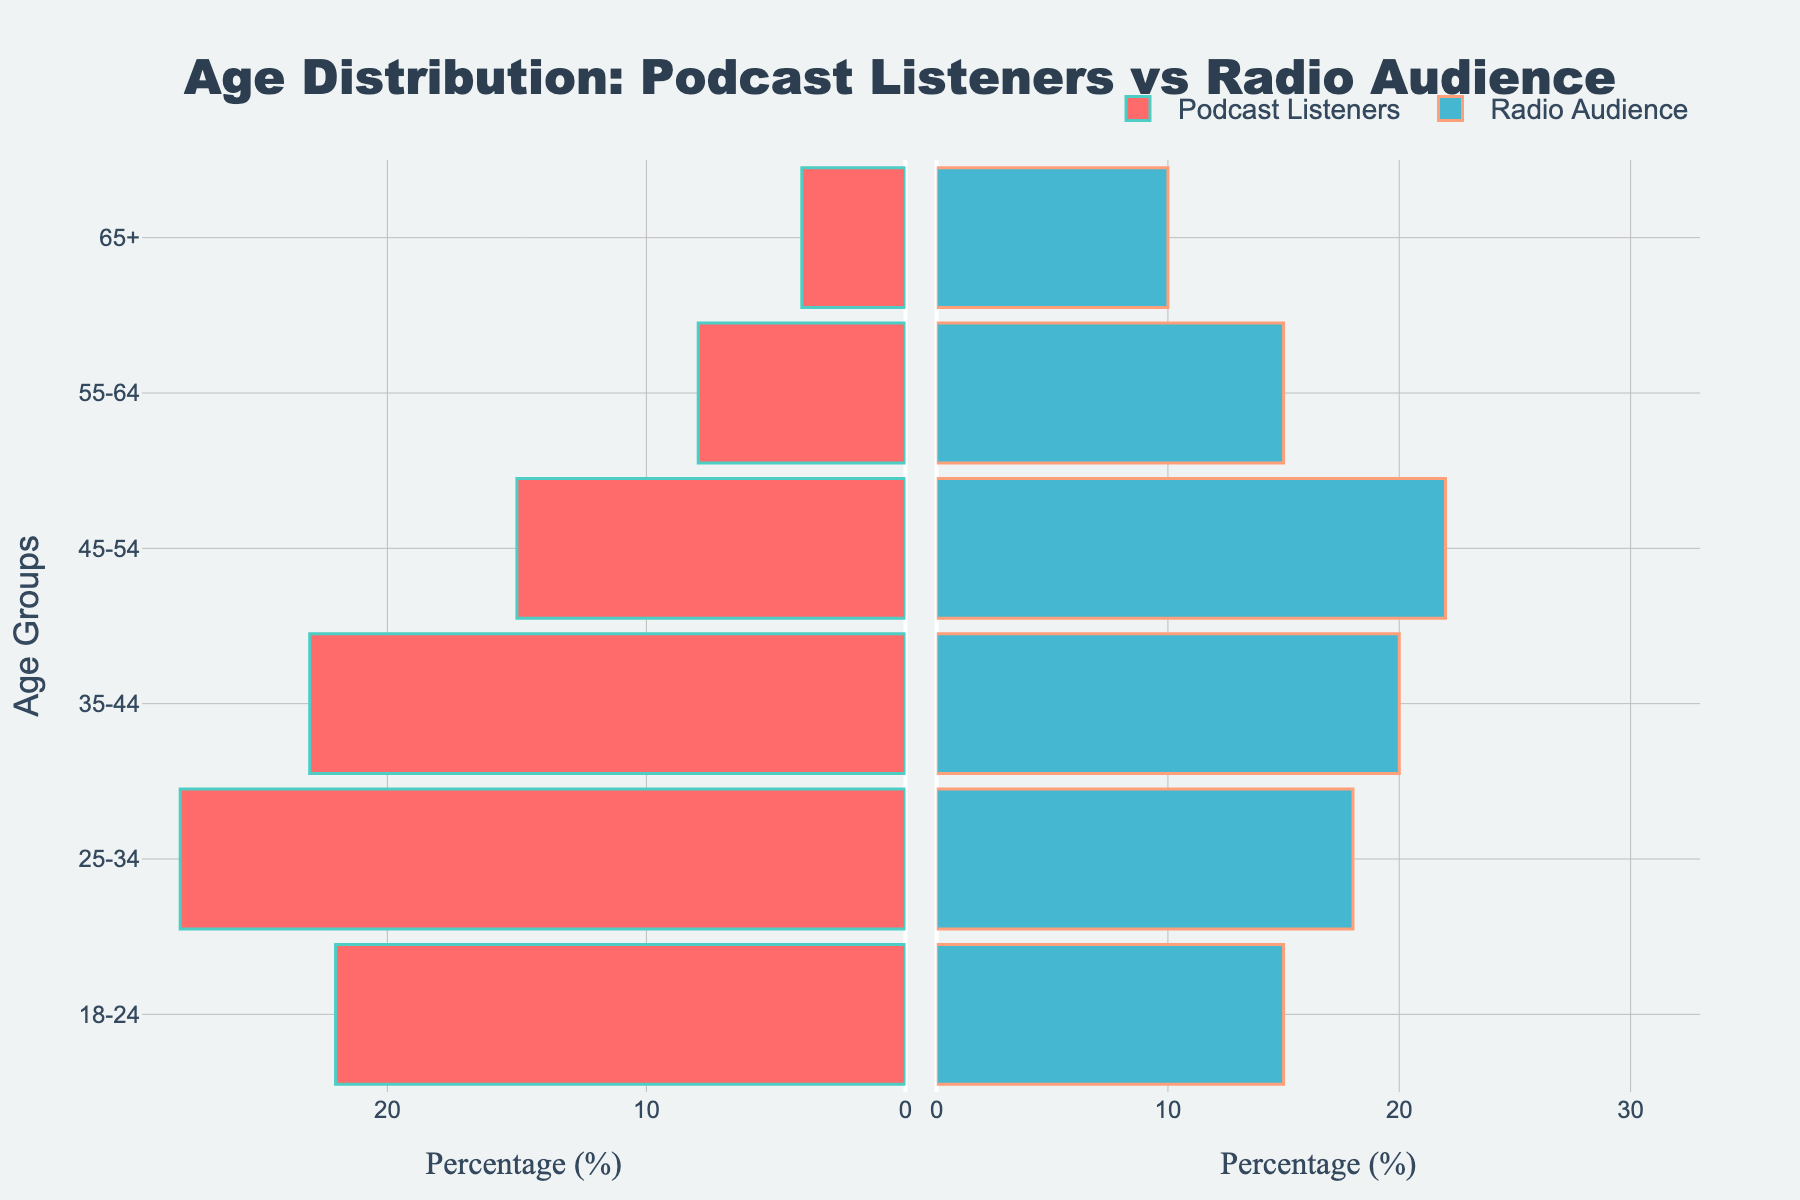What is the title of the figure? The title is displayed at the top of the figure.
Answer: Age Distribution: Podcast Listeners vs Radio Audience How does the number of listeners aged 18-24 compare between podcasts and traditional radio? The bar for Podcast Listeners in the 18-24 age group extends to 22%, while the bar for Radio Audience extends to 15%.
Answer: Podcast Listeners are higher What is the color used to represent Podcast Listeners in the figure? The color for Podcast Listeners is a visually distinguishable color, which is a shade of red.
Answer: Red Which age group has the highest percentage of Podcast Listeners? Inspecting the horizontal bars on the left side for Podcast Listeners, the age group 25-34 has the longest bar, indicating the highest percentage.
Answer: 25-34 By how much does the percentage of Radio Audience exceed Podcast Listeners in the 45-54 age group? The bar for Radio Audience in the 45-54 age group extends to 22%, while the Podcast Listeners bar extends to 15%. The difference is 22% - 15%.
Answer: 7% Which age group has the smallest percentage of Podcast Listeners and what is it? Observing the Podcast Listener bars, the 65+ age group has the shortest bar, indicating the smallest percentage, which is 4%.
Answer: 65+, 4% What is the combined percentage of Podcast Listeners aged 25-34 and 35-44? The percentage for 25-34 is 28%, and for 35-44 is 23%. Adding them together gives 28% + 23% = 51%.
Answer: 51% Which age group has more Radio Audience than Podcast Listeners and by how much in the 55-64 age group? The bar for Radio Audience in the 55-64 group extends to 15%, while the Podcast Listeners bar extends to 8%. The difference is 15% - 8%.
Answer: Radio Audience by 7% What visual element indicates the shared y-axis between the two subplots? The age groups listed along the y-axis are presented between the two subplots, indicating a shared y-axis.
Answer: Shared age groups Can you identify one age group where the Radio Audience is at least twice the Podcast Listeners? For the 65+ age group, the Radio Audience is 10% and the Podcast Listeners are 4%. 10% is more than twice 4%.
Answer: 65+ 